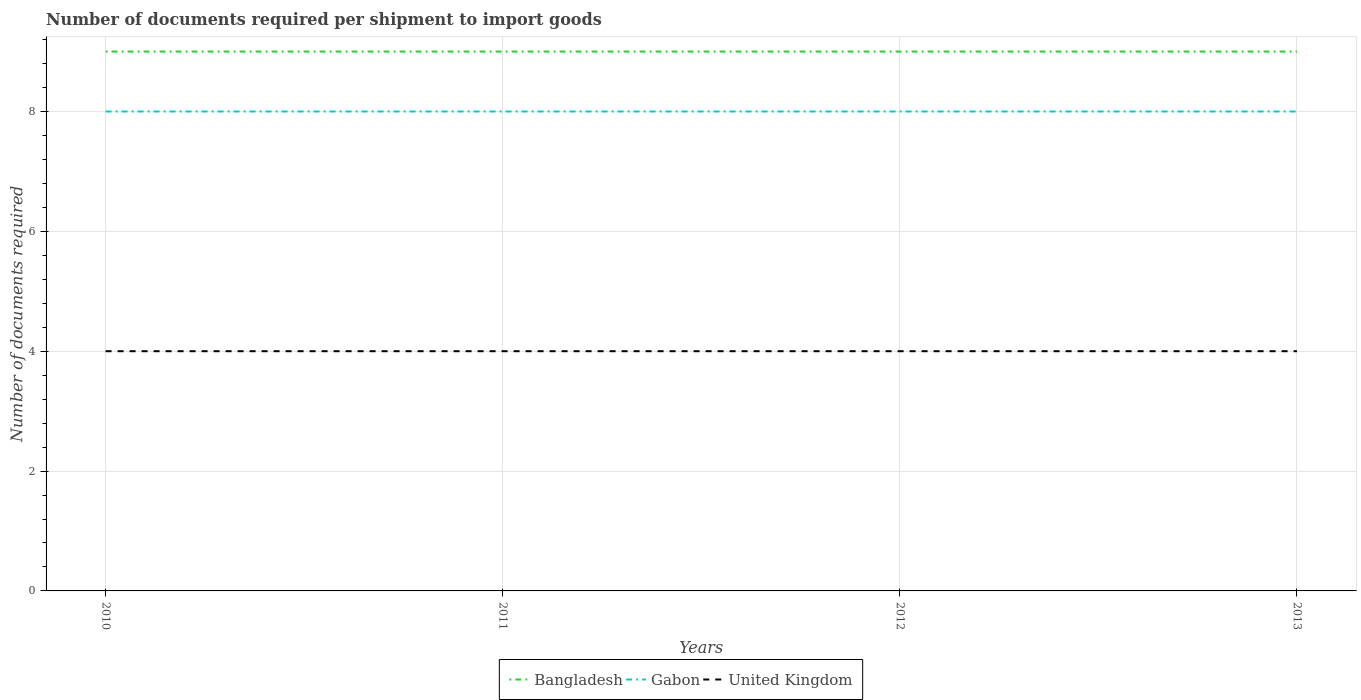How many different coloured lines are there?
Give a very brief answer. 3. Is the number of lines equal to the number of legend labels?
Make the answer very short. Yes. Across all years, what is the maximum number of documents required per shipment to import goods in United Kingdom?
Provide a short and direct response. 4. What is the difference between the highest and the lowest number of documents required per shipment to import goods in Gabon?
Provide a short and direct response. 0. Is the number of documents required per shipment to import goods in Gabon strictly greater than the number of documents required per shipment to import goods in United Kingdom over the years?
Your answer should be very brief. No. How many lines are there?
Your response must be concise. 3. What is the difference between two consecutive major ticks on the Y-axis?
Keep it short and to the point. 2. What is the title of the graph?
Your response must be concise. Number of documents required per shipment to import goods. What is the label or title of the Y-axis?
Ensure brevity in your answer.  Number of documents required. What is the Number of documents required in Bangladesh in 2010?
Your answer should be very brief. 9. What is the Number of documents required in Gabon in 2010?
Offer a very short reply. 8. What is the Number of documents required of Gabon in 2011?
Your answer should be compact. 8. What is the Number of documents required of United Kingdom in 2011?
Provide a short and direct response. 4. What is the Number of documents required in Bangladesh in 2012?
Your answer should be very brief. 9. What is the Number of documents required of United Kingdom in 2012?
Offer a very short reply. 4. What is the Number of documents required of Gabon in 2013?
Provide a succinct answer. 8. What is the Number of documents required in United Kingdom in 2013?
Offer a very short reply. 4. Across all years, what is the minimum Number of documents required in Bangladesh?
Provide a succinct answer. 9. Across all years, what is the minimum Number of documents required of Gabon?
Provide a short and direct response. 8. Across all years, what is the minimum Number of documents required of United Kingdom?
Offer a terse response. 4. What is the total Number of documents required of Gabon in the graph?
Provide a short and direct response. 32. What is the difference between the Number of documents required in Bangladesh in 2010 and that in 2011?
Provide a succinct answer. 0. What is the difference between the Number of documents required of Gabon in 2010 and that in 2011?
Make the answer very short. 0. What is the difference between the Number of documents required of United Kingdom in 2010 and that in 2011?
Keep it short and to the point. 0. What is the difference between the Number of documents required in Bangladesh in 2010 and that in 2013?
Give a very brief answer. 0. What is the difference between the Number of documents required of Gabon in 2010 and that in 2013?
Your response must be concise. 0. What is the difference between the Number of documents required of United Kingdom in 2010 and that in 2013?
Offer a terse response. 0. What is the difference between the Number of documents required of Bangladesh in 2011 and that in 2012?
Keep it short and to the point. 0. What is the difference between the Number of documents required in United Kingdom in 2011 and that in 2012?
Give a very brief answer. 0. What is the difference between the Number of documents required of Gabon in 2011 and that in 2013?
Ensure brevity in your answer.  0. What is the difference between the Number of documents required in United Kingdom in 2011 and that in 2013?
Offer a very short reply. 0. What is the difference between the Number of documents required in Bangladesh in 2012 and that in 2013?
Offer a very short reply. 0. What is the difference between the Number of documents required of Bangladesh in 2010 and the Number of documents required of Gabon in 2011?
Provide a short and direct response. 1. What is the difference between the Number of documents required in Bangladesh in 2010 and the Number of documents required in United Kingdom in 2011?
Provide a short and direct response. 5. What is the difference between the Number of documents required in Gabon in 2010 and the Number of documents required in United Kingdom in 2012?
Offer a terse response. 4. What is the difference between the Number of documents required in Bangladesh in 2010 and the Number of documents required in United Kingdom in 2013?
Offer a terse response. 5. What is the difference between the Number of documents required in Bangladesh in 2011 and the Number of documents required in Gabon in 2012?
Your response must be concise. 1. What is the difference between the Number of documents required in Bangladesh in 2012 and the Number of documents required in Gabon in 2013?
Your answer should be very brief. 1. What is the difference between the Number of documents required in Gabon in 2012 and the Number of documents required in United Kingdom in 2013?
Ensure brevity in your answer.  4. What is the average Number of documents required of Gabon per year?
Your answer should be very brief. 8. In the year 2010, what is the difference between the Number of documents required of Bangladesh and Number of documents required of Gabon?
Offer a very short reply. 1. In the year 2010, what is the difference between the Number of documents required of Bangladesh and Number of documents required of United Kingdom?
Give a very brief answer. 5. In the year 2011, what is the difference between the Number of documents required of Bangladesh and Number of documents required of Gabon?
Give a very brief answer. 1. In the year 2011, what is the difference between the Number of documents required in Bangladesh and Number of documents required in United Kingdom?
Your answer should be compact. 5. In the year 2011, what is the difference between the Number of documents required in Gabon and Number of documents required in United Kingdom?
Offer a terse response. 4. In the year 2012, what is the difference between the Number of documents required in Gabon and Number of documents required in United Kingdom?
Your response must be concise. 4. In the year 2013, what is the difference between the Number of documents required of Bangladesh and Number of documents required of Gabon?
Your answer should be very brief. 1. What is the ratio of the Number of documents required in United Kingdom in 2010 to that in 2011?
Keep it short and to the point. 1. What is the ratio of the Number of documents required of Gabon in 2010 to that in 2012?
Provide a short and direct response. 1. What is the ratio of the Number of documents required of Bangladesh in 2010 to that in 2013?
Offer a very short reply. 1. What is the ratio of the Number of documents required of Bangladesh in 2011 to that in 2012?
Offer a terse response. 1. What is the ratio of the Number of documents required of Gabon in 2011 to that in 2012?
Provide a short and direct response. 1. What is the ratio of the Number of documents required in Bangladesh in 2012 to that in 2013?
Provide a succinct answer. 1. What is the ratio of the Number of documents required in Gabon in 2012 to that in 2013?
Provide a short and direct response. 1. What is the ratio of the Number of documents required in United Kingdom in 2012 to that in 2013?
Your answer should be very brief. 1. What is the difference between the highest and the second highest Number of documents required of Gabon?
Ensure brevity in your answer.  0. What is the difference between the highest and the lowest Number of documents required in United Kingdom?
Your response must be concise. 0. 